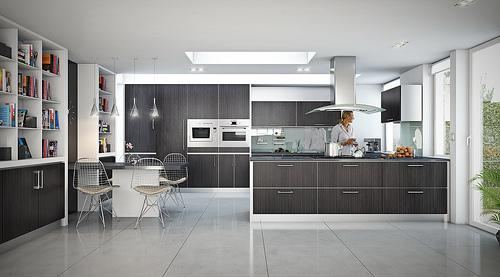Question: what room is shown?
Choices:
A. The dining room.
B. The living room.
C. The laundry room.
D. The kitchen.
Answer with the letter. Answer: D Question: how many chairs are around the table?
Choices:
A. Three.
B. Four.
C. Five.
D. Six.
Answer with the letter. Answer: A Question: where are the bookshelves?
Choices:
A. On the righthand side of the room.
B. On the far wall of the room.
C. By the closet.
D. On the lefthand side of the room.
Answer with the letter. Answer: D Question: what color are the cabinets?
Choices:
A. Grey.
B. Black.
C. Brown.
D. White.
Answer with the letter. Answer: A Question: when was the photo taken?
Choices:
A. During the morning.
B. During the daytime.
C. During the afternoon.
D. During daylight.
Answer with the letter. Answer: B Question: how many drawers are shown on the right hand side of the photo?
Choices:
A. Three.
B. Two.
C. SIx.
D. Four.
Answer with the letter. Answer: C 